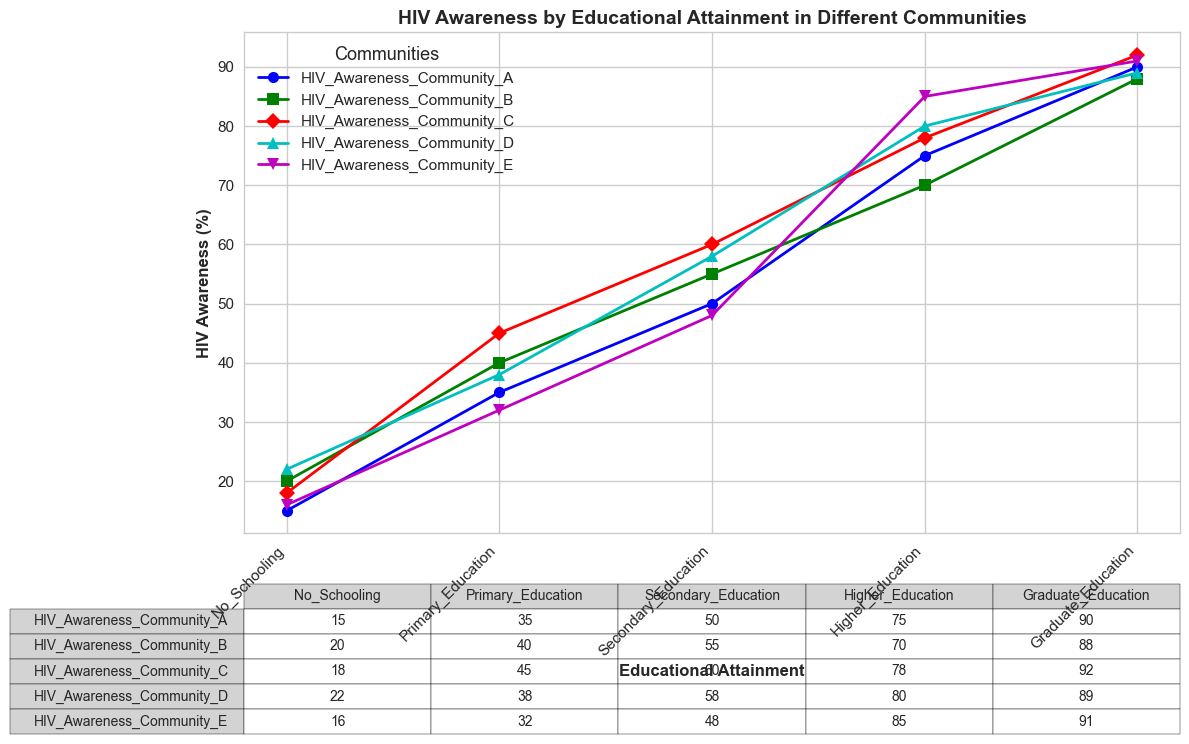What is the HIV awareness percentage for individuals with no schooling in Community B? Look at the table and the plotted line for Community B. The HIV awareness percentage for individuals with no schooling is denoted as 20% in Community B.
Answer: 20% Which community has the highest HIV awareness at the Graduate Education attainment level? Check the plotted lines or the table for the Graduate Education level, and note that the highest percent listed is for Community E at 91%.
Answer: Community E How does the HIV awareness percentage change from Secondary Education to Higher Education in Community A? In Community A, the awareness percentage for Secondary Education is 50%, and for Higher Education, it is 75%. Calculate the difference, which is 75% - 50% = 25%.
Answer: It increases by 25% Which community shows the least increase in HIV awareness from Primary Education to Secondary Education? Check the table for each community. The change in percentage is: 
Community A: 50% - 35% = 15%
Community B: 55% - 40% = 15%
Community C: 60% - 45% = 15%
Community D: 58% - 38% = 20%
Community E: 48% - 32% = 16%
Thus, Communities A, B, and C have the least increase, which is 15%.
Answer: Communities A, B, C What is the average HIV awareness percentage for Graduate Education across all communities? Sum the percentages for all communities at the Graduate Education level: (90% + 88% + 92% + 89% + 91%) = 450%. Divide by the number of communities, which is 5. The average is 450% / 5 = 90%.
Answer: 90% Which community shows the largest drop in HIV awareness from Higher Education to Graduate Education? Compare each community's percentages:
Community A: 90% - 75% = 15%
Community B: 88% - 70% = 18%
Community C: 92% - 78% = 14%
Community D: 89% - 80% = 9%
Community E: 91% - 85% = 6%
The largest drop is in Community B with an 18% decrease.
Answer: Community B What is the difference in HIV awareness for Primary Education between Community A and Community D? Community A has a Primary Education awareness of 35%, and Community D has 38%. Calculate the difference, which is 38% - 35% = 3%.
Answer: 3% For which educational attainment level do Communities C and D have the same HIV awareness percentage? By comparing the table, Secondary Education level has the same awareness percentage for Communities C and D at 60%.
Answer: Secondary Education At which educational attainment level does Community E have the greatest HIV awareness percentage improvement? Compare each percentage improvement:
No Schooling to Primary Education: 32% - 16% = 16%
Primary to Secondary Education: 48% - 32% = 16%
Secondary to Higher Education: 85% - 48% = 37%
Higher to Graduate Education: 91% - 85% = 6%
The greatest improvement is from Secondary to Higher Education with 37%.
Answer: Secondary to Higher Education 